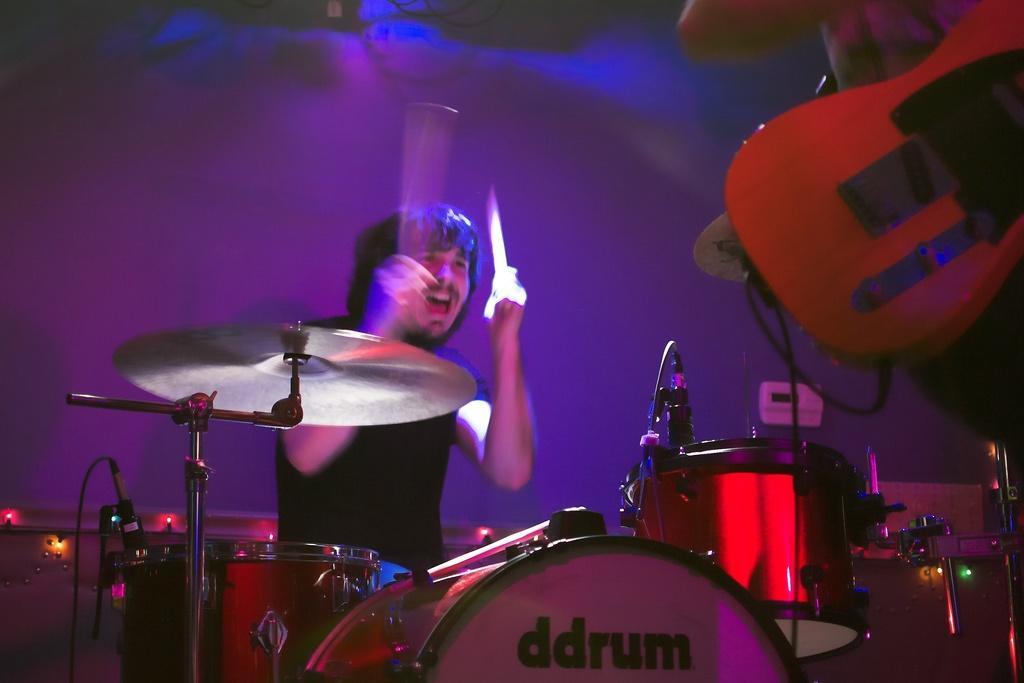Describe this image in one or two sentences. This picture consist of a man playing a musical drum which is in front of him. 